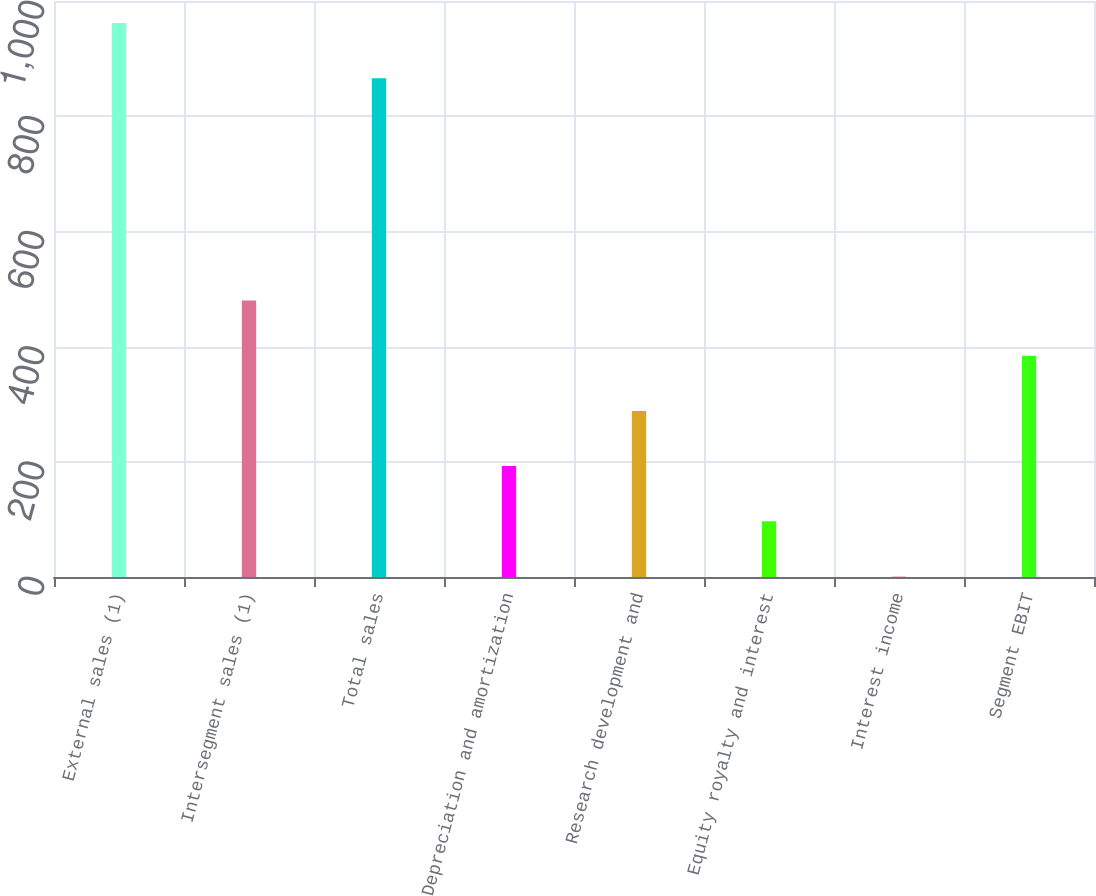Convert chart. <chart><loc_0><loc_0><loc_500><loc_500><bar_chart><fcel>External sales (1)<fcel>Intersegment sales (1)<fcel>Total sales<fcel>Depreciation and amortization<fcel>Research development and<fcel>Equity royalty and interest<fcel>Interest income<fcel>Segment EBIT<nl><fcel>961.8<fcel>480<fcel>866<fcel>192.6<fcel>288.4<fcel>96.8<fcel>1<fcel>384.2<nl></chart> 